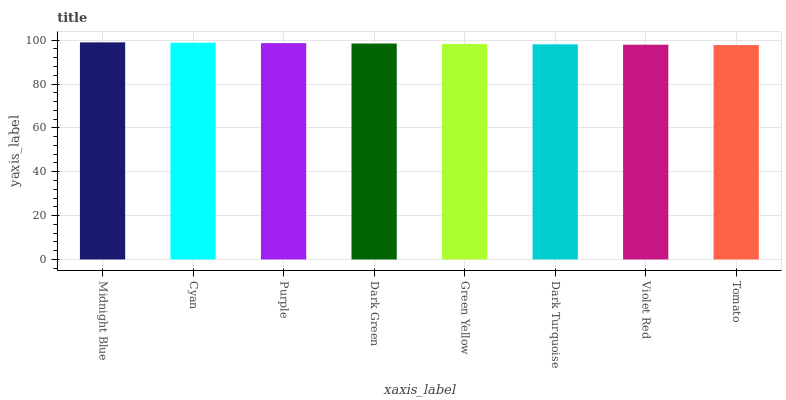Is Tomato the minimum?
Answer yes or no. Yes. Is Midnight Blue the maximum?
Answer yes or no. Yes. Is Cyan the minimum?
Answer yes or no. No. Is Cyan the maximum?
Answer yes or no. No. Is Midnight Blue greater than Cyan?
Answer yes or no. Yes. Is Cyan less than Midnight Blue?
Answer yes or no. Yes. Is Cyan greater than Midnight Blue?
Answer yes or no. No. Is Midnight Blue less than Cyan?
Answer yes or no. No. Is Dark Green the high median?
Answer yes or no. Yes. Is Green Yellow the low median?
Answer yes or no. Yes. Is Tomato the high median?
Answer yes or no. No. Is Tomato the low median?
Answer yes or no. No. 